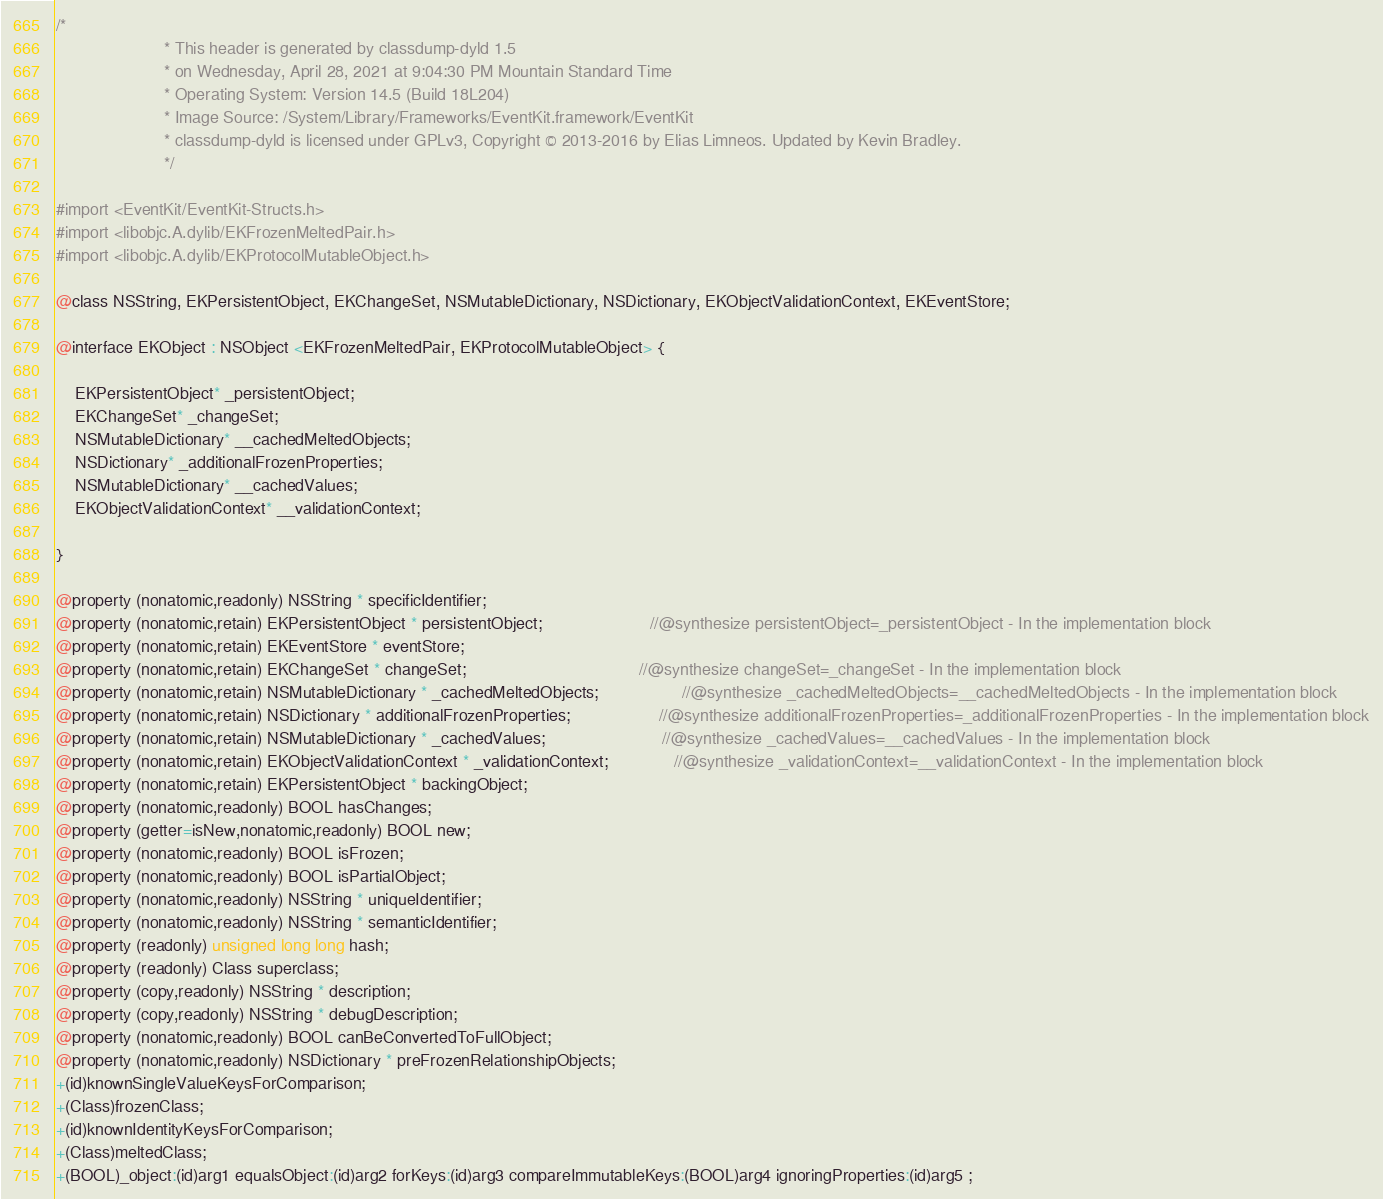<code> <loc_0><loc_0><loc_500><loc_500><_C_>/*
                       * This header is generated by classdump-dyld 1.5
                       * on Wednesday, April 28, 2021 at 9:04:30 PM Mountain Standard Time
                       * Operating System: Version 14.5 (Build 18L204)
                       * Image Source: /System/Library/Frameworks/EventKit.framework/EventKit
                       * classdump-dyld is licensed under GPLv3, Copyright © 2013-2016 by Elias Limneos. Updated by Kevin Bradley.
                       */

#import <EventKit/EventKit-Structs.h>
#import <libobjc.A.dylib/EKFrozenMeltedPair.h>
#import <libobjc.A.dylib/EKProtocolMutableObject.h>

@class NSString, EKPersistentObject, EKChangeSet, NSMutableDictionary, NSDictionary, EKObjectValidationContext, EKEventStore;

@interface EKObject : NSObject <EKFrozenMeltedPair, EKProtocolMutableObject> {

	EKPersistentObject* _persistentObject;
	EKChangeSet* _changeSet;
	NSMutableDictionary* __cachedMeltedObjects;
	NSDictionary* _additionalFrozenProperties;
	NSMutableDictionary* __cachedValues;
	EKObjectValidationContext* __validationContext;

}

@property (nonatomic,readonly) NSString * specificIdentifier; 
@property (nonatomic,retain) EKPersistentObject * persistentObject;                       //@synthesize persistentObject=_persistentObject - In the implementation block
@property (nonatomic,retain) EKEventStore * eventStore; 
@property (nonatomic,retain) EKChangeSet * changeSet;                                     //@synthesize changeSet=_changeSet - In the implementation block
@property (nonatomic,retain) NSMutableDictionary * _cachedMeltedObjects;                  //@synthesize _cachedMeltedObjects=__cachedMeltedObjects - In the implementation block
@property (nonatomic,retain) NSDictionary * additionalFrozenProperties;                   //@synthesize additionalFrozenProperties=_additionalFrozenProperties - In the implementation block
@property (nonatomic,retain) NSMutableDictionary * _cachedValues;                         //@synthesize _cachedValues=__cachedValues - In the implementation block
@property (nonatomic,retain) EKObjectValidationContext * _validationContext;              //@synthesize _validationContext=__validationContext - In the implementation block
@property (nonatomic,retain) EKPersistentObject * backingObject; 
@property (nonatomic,readonly) BOOL hasChanges; 
@property (getter=isNew,nonatomic,readonly) BOOL new; 
@property (nonatomic,readonly) BOOL isFrozen; 
@property (nonatomic,readonly) BOOL isPartialObject; 
@property (nonatomic,readonly) NSString * uniqueIdentifier; 
@property (nonatomic,readonly) NSString * semanticIdentifier; 
@property (readonly) unsigned long long hash; 
@property (readonly) Class superclass; 
@property (copy,readonly) NSString * description; 
@property (copy,readonly) NSString * debugDescription; 
@property (nonatomic,readonly) BOOL canBeConvertedToFullObject; 
@property (nonatomic,readonly) NSDictionary * preFrozenRelationshipObjects; 
+(id)knownSingleValueKeysForComparison;
+(Class)frozenClass;
+(id)knownIdentityKeysForComparison;
+(Class)meltedClass;
+(BOOL)_object:(id)arg1 equalsObject:(id)arg2 forKeys:(id)arg3 compareImmutableKeys:(BOOL)arg4 ignoringProperties:(id)arg5 ;</code> 